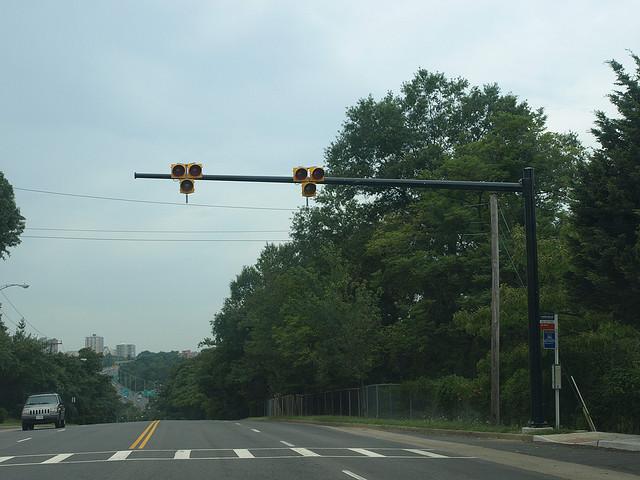How many cars are on the road?
Give a very brief answer. 1. How many traffic lights can you see?
Give a very brief answer. 2. How many people are in the image?
Give a very brief answer. 0. 